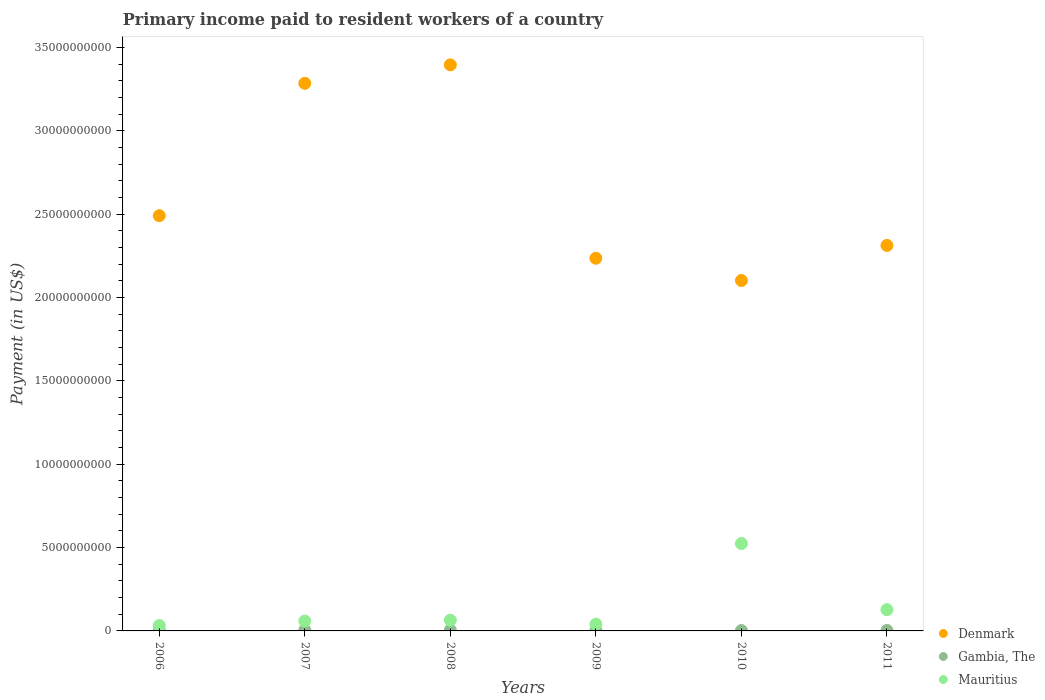How many different coloured dotlines are there?
Provide a short and direct response. 3. What is the amount paid to workers in Mauritius in 2011?
Make the answer very short. 1.28e+09. Across all years, what is the maximum amount paid to workers in Denmark?
Keep it short and to the point. 3.40e+1. Across all years, what is the minimum amount paid to workers in Mauritius?
Your answer should be very brief. 3.24e+08. What is the total amount paid to workers in Denmark in the graph?
Your answer should be very brief. 1.58e+11. What is the difference between the amount paid to workers in Mauritius in 2006 and that in 2008?
Your answer should be very brief. -3.18e+08. What is the difference between the amount paid to workers in Mauritius in 2006 and the amount paid to workers in Gambia, The in 2009?
Ensure brevity in your answer.  3.04e+08. What is the average amount paid to workers in Denmark per year?
Make the answer very short. 2.64e+1. In the year 2006, what is the difference between the amount paid to workers in Mauritius and amount paid to workers in Denmark?
Your answer should be compact. -2.46e+1. In how many years, is the amount paid to workers in Mauritius greater than 16000000000 US$?
Keep it short and to the point. 0. What is the ratio of the amount paid to workers in Denmark in 2010 to that in 2011?
Give a very brief answer. 0.91. Is the amount paid to workers in Mauritius in 2006 less than that in 2011?
Provide a short and direct response. Yes. What is the difference between the highest and the second highest amount paid to workers in Gambia, The?
Make the answer very short. 6.37e+06. What is the difference between the highest and the lowest amount paid to workers in Denmark?
Make the answer very short. 1.29e+1. In how many years, is the amount paid to workers in Denmark greater than the average amount paid to workers in Denmark taken over all years?
Offer a terse response. 2. Is the sum of the amount paid to workers in Gambia, The in 2007 and 2009 greater than the maximum amount paid to workers in Denmark across all years?
Keep it short and to the point. No. Is it the case that in every year, the sum of the amount paid to workers in Gambia, The and amount paid to workers in Mauritius  is greater than the amount paid to workers in Denmark?
Provide a succinct answer. No. Is the amount paid to workers in Gambia, The strictly greater than the amount paid to workers in Mauritius over the years?
Ensure brevity in your answer.  No. Is the amount paid to workers in Denmark strictly less than the amount paid to workers in Mauritius over the years?
Give a very brief answer. No. How many years are there in the graph?
Ensure brevity in your answer.  6. Does the graph contain any zero values?
Keep it short and to the point. No. Does the graph contain grids?
Ensure brevity in your answer.  No. What is the title of the graph?
Your response must be concise. Primary income paid to resident workers of a country. Does "Syrian Arab Republic" appear as one of the legend labels in the graph?
Make the answer very short. No. What is the label or title of the Y-axis?
Provide a succinct answer. Payment (in US$). What is the Payment (in US$) of Denmark in 2006?
Your answer should be very brief. 2.49e+1. What is the Payment (in US$) of Gambia, The in 2006?
Ensure brevity in your answer.  4.24e+07. What is the Payment (in US$) of Mauritius in 2006?
Provide a succinct answer. 3.24e+08. What is the Payment (in US$) in Denmark in 2007?
Provide a short and direct response. 3.29e+1. What is the Payment (in US$) in Gambia, The in 2007?
Make the answer very short. 5.35e+07. What is the Payment (in US$) in Mauritius in 2007?
Your response must be concise. 5.93e+08. What is the Payment (in US$) in Denmark in 2008?
Ensure brevity in your answer.  3.40e+1. What is the Payment (in US$) in Gambia, The in 2008?
Your answer should be very brief. 4.72e+07. What is the Payment (in US$) of Mauritius in 2008?
Provide a succinct answer. 6.42e+08. What is the Payment (in US$) of Denmark in 2009?
Give a very brief answer. 2.24e+1. What is the Payment (in US$) of Gambia, The in 2009?
Ensure brevity in your answer.  1.98e+07. What is the Payment (in US$) of Mauritius in 2009?
Your response must be concise. 4.03e+08. What is the Payment (in US$) in Denmark in 2010?
Provide a succinct answer. 2.10e+1. What is the Payment (in US$) of Gambia, The in 2010?
Ensure brevity in your answer.  2.24e+07. What is the Payment (in US$) of Mauritius in 2010?
Your response must be concise. 5.24e+09. What is the Payment (in US$) in Denmark in 2011?
Your answer should be very brief. 2.31e+1. What is the Payment (in US$) in Gambia, The in 2011?
Make the answer very short. 2.88e+07. What is the Payment (in US$) in Mauritius in 2011?
Give a very brief answer. 1.28e+09. Across all years, what is the maximum Payment (in US$) of Denmark?
Give a very brief answer. 3.40e+1. Across all years, what is the maximum Payment (in US$) in Gambia, The?
Keep it short and to the point. 5.35e+07. Across all years, what is the maximum Payment (in US$) of Mauritius?
Offer a very short reply. 5.24e+09. Across all years, what is the minimum Payment (in US$) in Denmark?
Ensure brevity in your answer.  2.10e+1. Across all years, what is the minimum Payment (in US$) in Gambia, The?
Make the answer very short. 1.98e+07. Across all years, what is the minimum Payment (in US$) in Mauritius?
Your answer should be very brief. 3.24e+08. What is the total Payment (in US$) of Denmark in the graph?
Your answer should be compact. 1.58e+11. What is the total Payment (in US$) of Gambia, The in the graph?
Provide a succinct answer. 2.14e+08. What is the total Payment (in US$) of Mauritius in the graph?
Provide a short and direct response. 8.48e+09. What is the difference between the Payment (in US$) in Denmark in 2006 and that in 2007?
Your answer should be compact. -7.94e+09. What is the difference between the Payment (in US$) in Gambia, The in 2006 and that in 2007?
Offer a terse response. -1.11e+07. What is the difference between the Payment (in US$) of Mauritius in 2006 and that in 2007?
Your answer should be very brief. -2.69e+08. What is the difference between the Payment (in US$) in Denmark in 2006 and that in 2008?
Make the answer very short. -9.05e+09. What is the difference between the Payment (in US$) in Gambia, The in 2006 and that in 2008?
Your answer should be very brief. -4.76e+06. What is the difference between the Payment (in US$) of Mauritius in 2006 and that in 2008?
Give a very brief answer. -3.18e+08. What is the difference between the Payment (in US$) in Denmark in 2006 and that in 2009?
Offer a terse response. 2.55e+09. What is the difference between the Payment (in US$) of Gambia, The in 2006 and that in 2009?
Ensure brevity in your answer.  2.26e+07. What is the difference between the Payment (in US$) of Mauritius in 2006 and that in 2009?
Offer a very short reply. -7.88e+07. What is the difference between the Payment (in US$) of Denmark in 2006 and that in 2010?
Give a very brief answer. 3.89e+09. What is the difference between the Payment (in US$) in Gambia, The in 2006 and that in 2010?
Offer a terse response. 2.00e+07. What is the difference between the Payment (in US$) of Mauritius in 2006 and that in 2010?
Your answer should be very brief. -4.92e+09. What is the difference between the Payment (in US$) of Denmark in 2006 and that in 2011?
Provide a short and direct response. 1.79e+09. What is the difference between the Payment (in US$) of Gambia, The in 2006 and that in 2011?
Your answer should be compact. 1.36e+07. What is the difference between the Payment (in US$) in Mauritius in 2006 and that in 2011?
Provide a short and direct response. -9.52e+08. What is the difference between the Payment (in US$) in Denmark in 2007 and that in 2008?
Offer a terse response. -1.11e+09. What is the difference between the Payment (in US$) of Gambia, The in 2007 and that in 2008?
Offer a very short reply. 6.37e+06. What is the difference between the Payment (in US$) of Mauritius in 2007 and that in 2008?
Give a very brief answer. -4.84e+07. What is the difference between the Payment (in US$) in Denmark in 2007 and that in 2009?
Offer a terse response. 1.05e+1. What is the difference between the Payment (in US$) in Gambia, The in 2007 and that in 2009?
Your answer should be very brief. 3.37e+07. What is the difference between the Payment (in US$) in Mauritius in 2007 and that in 2009?
Provide a succinct answer. 1.91e+08. What is the difference between the Payment (in US$) of Denmark in 2007 and that in 2010?
Provide a succinct answer. 1.18e+1. What is the difference between the Payment (in US$) of Gambia, The in 2007 and that in 2010?
Keep it short and to the point. 3.11e+07. What is the difference between the Payment (in US$) of Mauritius in 2007 and that in 2010?
Give a very brief answer. -4.65e+09. What is the difference between the Payment (in US$) in Denmark in 2007 and that in 2011?
Keep it short and to the point. 9.73e+09. What is the difference between the Payment (in US$) in Gambia, The in 2007 and that in 2011?
Provide a short and direct response. 2.47e+07. What is the difference between the Payment (in US$) in Mauritius in 2007 and that in 2011?
Provide a succinct answer. -6.83e+08. What is the difference between the Payment (in US$) in Denmark in 2008 and that in 2009?
Give a very brief answer. 1.16e+1. What is the difference between the Payment (in US$) in Gambia, The in 2008 and that in 2009?
Make the answer very short. 2.74e+07. What is the difference between the Payment (in US$) in Mauritius in 2008 and that in 2009?
Provide a succinct answer. 2.39e+08. What is the difference between the Payment (in US$) of Denmark in 2008 and that in 2010?
Keep it short and to the point. 1.29e+1. What is the difference between the Payment (in US$) of Gambia, The in 2008 and that in 2010?
Give a very brief answer. 2.48e+07. What is the difference between the Payment (in US$) in Mauritius in 2008 and that in 2010?
Your answer should be very brief. -4.60e+09. What is the difference between the Payment (in US$) in Denmark in 2008 and that in 2011?
Keep it short and to the point. 1.08e+1. What is the difference between the Payment (in US$) in Gambia, The in 2008 and that in 2011?
Give a very brief answer. 1.84e+07. What is the difference between the Payment (in US$) of Mauritius in 2008 and that in 2011?
Provide a succinct answer. -6.34e+08. What is the difference between the Payment (in US$) in Denmark in 2009 and that in 2010?
Ensure brevity in your answer.  1.33e+09. What is the difference between the Payment (in US$) in Gambia, The in 2009 and that in 2010?
Keep it short and to the point. -2.62e+06. What is the difference between the Payment (in US$) in Mauritius in 2009 and that in 2010?
Make the answer very short. -4.84e+09. What is the difference between the Payment (in US$) of Denmark in 2009 and that in 2011?
Your answer should be very brief. -7.68e+08. What is the difference between the Payment (in US$) in Gambia, The in 2009 and that in 2011?
Provide a short and direct response. -9.02e+06. What is the difference between the Payment (in US$) of Mauritius in 2009 and that in 2011?
Offer a terse response. -8.74e+08. What is the difference between the Payment (in US$) in Denmark in 2010 and that in 2011?
Make the answer very short. -2.10e+09. What is the difference between the Payment (in US$) of Gambia, The in 2010 and that in 2011?
Your answer should be very brief. -6.40e+06. What is the difference between the Payment (in US$) in Mauritius in 2010 and that in 2011?
Provide a succinct answer. 3.97e+09. What is the difference between the Payment (in US$) in Denmark in 2006 and the Payment (in US$) in Gambia, The in 2007?
Provide a short and direct response. 2.49e+1. What is the difference between the Payment (in US$) of Denmark in 2006 and the Payment (in US$) of Mauritius in 2007?
Your answer should be compact. 2.43e+1. What is the difference between the Payment (in US$) in Gambia, The in 2006 and the Payment (in US$) in Mauritius in 2007?
Make the answer very short. -5.51e+08. What is the difference between the Payment (in US$) of Denmark in 2006 and the Payment (in US$) of Gambia, The in 2008?
Offer a very short reply. 2.49e+1. What is the difference between the Payment (in US$) of Denmark in 2006 and the Payment (in US$) of Mauritius in 2008?
Make the answer very short. 2.43e+1. What is the difference between the Payment (in US$) in Gambia, The in 2006 and the Payment (in US$) in Mauritius in 2008?
Provide a succinct answer. -5.99e+08. What is the difference between the Payment (in US$) in Denmark in 2006 and the Payment (in US$) in Gambia, The in 2009?
Provide a short and direct response. 2.49e+1. What is the difference between the Payment (in US$) in Denmark in 2006 and the Payment (in US$) in Mauritius in 2009?
Provide a short and direct response. 2.45e+1. What is the difference between the Payment (in US$) of Gambia, The in 2006 and the Payment (in US$) of Mauritius in 2009?
Ensure brevity in your answer.  -3.60e+08. What is the difference between the Payment (in US$) of Denmark in 2006 and the Payment (in US$) of Gambia, The in 2010?
Offer a terse response. 2.49e+1. What is the difference between the Payment (in US$) of Denmark in 2006 and the Payment (in US$) of Mauritius in 2010?
Your response must be concise. 1.97e+1. What is the difference between the Payment (in US$) of Gambia, The in 2006 and the Payment (in US$) of Mauritius in 2010?
Your answer should be very brief. -5.20e+09. What is the difference between the Payment (in US$) in Denmark in 2006 and the Payment (in US$) in Gambia, The in 2011?
Offer a terse response. 2.49e+1. What is the difference between the Payment (in US$) in Denmark in 2006 and the Payment (in US$) in Mauritius in 2011?
Your answer should be compact. 2.36e+1. What is the difference between the Payment (in US$) in Gambia, The in 2006 and the Payment (in US$) in Mauritius in 2011?
Make the answer very short. -1.23e+09. What is the difference between the Payment (in US$) of Denmark in 2007 and the Payment (in US$) of Gambia, The in 2008?
Your answer should be very brief. 3.28e+1. What is the difference between the Payment (in US$) of Denmark in 2007 and the Payment (in US$) of Mauritius in 2008?
Your response must be concise. 3.22e+1. What is the difference between the Payment (in US$) in Gambia, The in 2007 and the Payment (in US$) in Mauritius in 2008?
Keep it short and to the point. -5.88e+08. What is the difference between the Payment (in US$) in Denmark in 2007 and the Payment (in US$) in Gambia, The in 2009?
Your answer should be very brief. 3.28e+1. What is the difference between the Payment (in US$) of Denmark in 2007 and the Payment (in US$) of Mauritius in 2009?
Make the answer very short. 3.24e+1. What is the difference between the Payment (in US$) in Gambia, The in 2007 and the Payment (in US$) in Mauritius in 2009?
Ensure brevity in your answer.  -3.49e+08. What is the difference between the Payment (in US$) of Denmark in 2007 and the Payment (in US$) of Gambia, The in 2010?
Your response must be concise. 3.28e+1. What is the difference between the Payment (in US$) in Denmark in 2007 and the Payment (in US$) in Mauritius in 2010?
Your response must be concise. 2.76e+1. What is the difference between the Payment (in US$) in Gambia, The in 2007 and the Payment (in US$) in Mauritius in 2010?
Offer a very short reply. -5.19e+09. What is the difference between the Payment (in US$) in Denmark in 2007 and the Payment (in US$) in Gambia, The in 2011?
Offer a very short reply. 3.28e+1. What is the difference between the Payment (in US$) of Denmark in 2007 and the Payment (in US$) of Mauritius in 2011?
Ensure brevity in your answer.  3.16e+1. What is the difference between the Payment (in US$) in Gambia, The in 2007 and the Payment (in US$) in Mauritius in 2011?
Keep it short and to the point. -1.22e+09. What is the difference between the Payment (in US$) of Denmark in 2008 and the Payment (in US$) of Gambia, The in 2009?
Offer a very short reply. 3.39e+1. What is the difference between the Payment (in US$) of Denmark in 2008 and the Payment (in US$) of Mauritius in 2009?
Your answer should be compact. 3.36e+1. What is the difference between the Payment (in US$) in Gambia, The in 2008 and the Payment (in US$) in Mauritius in 2009?
Provide a short and direct response. -3.55e+08. What is the difference between the Payment (in US$) of Denmark in 2008 and the Payment (in US$) of Gambia, The in 2010?
Make the answer very short. 3.39e+1. What is the difference between the Payment (in US$) of Denmark in 2008 and the Payment (in US$) of Mauritius in 2010?
Provide a short and direct response. 2.87e+1. What is the difference between the Payment (in US$) in Gambia, The in 2008 and the Payment (in US$) in Mauritius in 2010?
Offer a terse response. -5.19e+09. What is the difference between the Payment (in US$) in Denmark in 2008 and the Payment (in US$) in Gambia, The in 2011?
Provide a succinct answer. 3.39e+1. What is the difference between the Payment (in US$) in Denmark in 2008 and the Payment (in US$) in Mauritius in 2011?
Make the answer very short. 3.27e+1. What is the difference between the Payment (in US$) of Gambia, The in 2008 and the Payment (in US$) of Mauritius in 2011?
Your answer should be very brief. -1.23e+09. What is the difference between the Payment (in US$) of Denmark in 2009 and the Payment (in US$) of Gambia, The in 2010?
Make the answer very short. 2.23e+1. What is the difference between the Payment (in US$) in Denmark in 2009 and the Payment (in US$) in Mauritius in 2010?
Ensure brevity in your answer.  1.71e+1. What is the difference between the Payment (in US$) of Gambia, The in 2009 and the Payment (in US$) of Mauritius in 2010?
Ensure brevity in your answer.  -5.22e+09. What is the difference between the Payment (in US$) of Denmark in 2009 and the Payment (in US$) of Gambia, The in 2011?
Ensure brevity in your answer.  2.23e+1. What is the difference between the Payment (in US$) in Denmark in 2009 and the Payment (in US$) in Mauritius in 2011?
Offer a terse response. 2.11e+1. What is the difference between the Payment (in US$) in Gambia, The in 2009 and the Payment (in US$) in Mauritius in 2011?
Your answer should be very brief. -1.26e+09. What is the difference between the Payment (in US$) in Denmark in 2010 and the Payment (in US$) in Gambia, The in 2011?
Give a very brief answer. 2.10e+1. What is the difference between the Payment (in US$) in Denmark in 2010 and the Payment (in US$) in Mauritius in 2011?
Offer a very short reply. 1.97e+1. What is the difference between the Payment (in US$) of Gambia, The in 2010 and the Payment (in US$) of Mauritius in 2011?
Give a very brief answer. -1.25e+09. What is the average Payment (in US$) of Denmark per year?
Give a very brief answer. 2.64e+1. What is the average Payment (in US$) of Gambia, The per year?
Your answer should be compact. 3.57e+07. What is the average Payment (in US$) in Mauritius per year?
Provide a short and direct response. 1.41e+09. In the year 2006, what is the difference between the Payment (in US$) of Denmark and Payment (in US$) of Gambia, The?
Your response must be concise. 2.49e+1. In the year 2006, what is the difference between the Payment (in US$) of Denmark and Payment (in US$) of Mauritius?
Offer a very short reply. 2.46e+1. In the year 2006, what is the difference between the Payment (in US$) of Gambia, The and Payment (in US$) of Mauritius?
Provide a short and direct response. -2.81e+08. In the year 2007, what is the difference between the Payment (in US$) in Denmark and Payment (in US$) in Gambia, The?
Offer a very short reply. 3.28e+1. In the year 2007, what is the difference between the Payment (in US$) in Denmark and Payment (in US$) in Mauritius?
Offer a very short reply. 3.23e+1. In the year 2007, what is the difference between the Payment (in US$) in Gambia, The and Payment (in US$) in Mauritius?
Provide a succinct answer. -5.40e+08. In the year 2008, what is the difference between the Payment (in US$) of Denmark and Payment (in US$) of Gambia, The?
Keep it short and to the point. 3.39e+1. In the year 2008, what is the difference between the Payment (in US$) of Denmark and Payment (in US$) of Mauritius?
Your answer should be very brief. 3.33e+1. In the year 2008, what is the difference between the Payment (in US$) in Gambia, The and Payment (in US$) in Mauritius?
Your response must be concise. -5.95e+08. In the year 2009, what is the difference between the Payment (in US$) in Denmark and Payment (in US$) in Gambia, The?
Give a very brief answer. 2.23e+1. In the year 2009, what is the difference between the Payment (in US$) of Denmark and Payment (in US$) of Mauritius?
Your answer should be very brief. 2.20e+1. In the year 2009, what is the difference between the Payment (in US$) of Gambia, The and Payment (in US$) of Mauritius?
Make the answer very short. -3.83e+08. In the year 2010, what is the difference between the Payment (in US$) in Denmark and Payment (in US$) in Gambia, The?
Your response must be concise. 2.10e+1. In the year 2010, what is the difference between the Payment (in US$) in Denmark and Payment (in US$) in Mauritius?
Keep it short and to the point. 1.58e+1. In the year 2010, what is the difference between the Payment (in US$) of Gambia, The and Payment (in US$) of Mauritius?
Provide a succinct answer. -5.22e+09. In the year 2011, what is the difference between the Payment (in US$) in Denmark and Payment (in US$) in Gambia, The?
Offer a very short reply. 2.31e+1. In the year 2011, what is the difference between the Payment (in US$) of Denmark and Payment (in US$) of Mauritius?
Provide a succinct answer. 2.18e+1. In the year 2011, what is the difference between the Payment (in US$) of Gambia, The and Payment (in US$) of Mauritius?
Offer a very short reply. -1.25e+09. What is the ratio of the Payment (in US$) of Denmark in 2006 to that in 2007?
Provide a succinct answer. 0.76. What is the ratio of the Payment (in US$) in Gambia, The in 2006 to that in 2007?
Give a very brief answer. 0.79. What is the ratio of the Payment (in US$) in Mauritius in 2006 to that in 2007?
Provide a succinct answer. 0.55. What is the ratio of the Payment (in US$) in Denmark in 2006 to that in 2008?
Your answer should be compact. 0.73. What is the ratio of the Payment (in US$) in Gambia, The in 2006 to that in 2008?
Your answer should be compact. 0.9. What is the ratio of the Payment (in US$) of Mauritius in 2006 to that in 2008?
Your answer should be compact. 0.5. What is the ratio of the Payment (in US$) in Denmark in 2006 to that in 2009?
Offer a terse response. 1.11. What is the ratio of the Payment (in US$) of Gambia, The in 2006 to that in 2009?
Make the answer very short. 2.14. What is the ratio of the Payment (in US$) of Mauritius in 2006 to that in 2009?
Provide a short and direct response. 0.8. What is the ratio of the Payment (in US$) in Denmark in 2006 to that in 2010?
Offer a terse response. 1.19. What is the ratio of the Payment (in US$) of Gambia, The in 2006 to that in 2010?
Your answer should be very brief. 1.89. What is the ratio of the Payment (in US$) in Mauritius in 2006 to that in 2010?
Your answer should be very brief. 0.06. What is the ratio of the Payment (in US$) in Denmark in 2006 to that in 2011?
Make the answer very short. 1.08. What is the ratio of the Payment (in US$) of Gambia, The in 2006 to that in 2011?
Ensure brevity in your answer.  1.47. What is the ratio of the Payment (in US$) of Mauritius in 2006 to that in 2011?
Keep it short and to the point. 0.25. What is the ratio of the Payment (in US$) in Denmark in 2007 to that in 2008?
Ensure brevity in your answer.  0.97. What is the ratio of the Payment (in US$) in Gambia, The in 2007 to that in 2008?
Your answer should be compact. 1.14. What is the ratio of the Payment (in US$) in Mauritius in 2007 to that in 2008?
Keep it short and to the point. 0.92. What is the ratio of the Payment (in US$) in Denmark in 2007 to that in 2009?
Your answer should be compact. 1.47. What is the ratio of the Payment (in US$) of Gambia, The in 2007 to that in 2009?
Provide a short and direct response. 2.71. What is the ratio of the Payment (in US$) of Mauritius in 2007 to that in 2009?
Your response must be concise. 1.47. What is the ratio of the Payment (in US$) in Denmark in 2007 to that in 2010?
Your answer should be compact. 1.56. What is the ratio of the Payment (in US$) of Gambia, The in 2007 to that in 2010?
Ensure brevity in your answer.  2.39. What is the ratio of the Payment (in US$) of Mauritius in 2007 to that in 2010?
Provide a succinct answer. 0.11. What is the ratio of the Payment (in US$) of Denmark in 2007 to that in 2011?
Ensure brevity in your answer.  1.42. What is the ratio of the Payment (in US$) of Gambia, The in 2007 to that in 2011?
Make the answer very short. 1.86. What is the ratio of the Payment (in US$) in Mauritius in 2007 to that in 2011?
Your answer should be compact. 0.46. What is the ratio of the Payment (in US$) of Denmark in 2008 to that in 2009?
Offer a very short reply. 1.52. What is the ratio of the Payment (in US$) in Gambia, The in 2008 to that in 2009?
Offer a terse response. 2.38. What is the ratio of the Payment (in US$) of Mauritius in 2008 to that in 2009?
Provide a short and direct response. 1.59. What is the ratio of the Payment (in US$) in Denmark in 2008 to that in 2010?
Your answer should be very brief. 1.62. What is the ratio of the Payment (in US$) in Gambia, The in 2008 to that in 2010?
Give a very brief answer. 2.11. What is the ratio of the Payment (in US$) in Mauritius in 2008 to that in 2010?
Your response must be concise. 0.12. What is the ratio of the Payment (in US$) of Denmark in 2008 to that in 2011?
Give a very brief answer. 1.47. What is the ratio of the Payment (in US$) of Gambia, The in 2008 to that in 2011?
Provide a succinct answer. 1.64. What is the ratio of the Payment (in US$) in Mauritius in 2008 to that in 2011?
Make the answer very short. 0.5. What is the ratio of the Payment (in US$) of Denmark in 2009 to that in 2010?
Offer a very short reply. 1.06. What is the ratio of the Payment (in US$) in Gambia, The in 2009 to that in 2010?
Keep it short and to the point. 0.88. What is the ratio of the Payment (in US$) in Mauritius in 2009 to that in 2010?
Give a very brief answer. 0.08. What is the ratio of the Payment (in US$) of Denmark in 2009 to that in 2011?
Offer a terse response. 0.97. What is the ratio of the Payment (in US$) in Gambia, The in 2009 to that in 2011?
Your answer should be compact. 0.69. What is the ratio of the Payment (in US$) in Mauritius in 2009 to that in 2011?
Offer a very short reply. 0.32. What is the ratio of the Payment (in US$) in Denmark in 2010 to that in 2011?
Your answer should be compact. 0.91. What is the ratio of the Payment (in US$) in Gambia, The in 2010 to that in 2011?
Offer a terse response. 0.78. What is the ratio of the Payment (in US$) of Mauritius in 2010 to that in 2011?
Your response must be concise. 4.11. What is the difference between the highest and the second highest Payment (in US$) of Denmark?
Your answer should be very brief. 1.11e+09. What is the difference between the highest and the second highest Payment (in US$) in Gambia, The?
Your answer should be very brief. 6.37e+06. What is the difference between the highest and the second highest Payment (in US$) in Mauritius?
Keep it short and to the point. 3.97e+09. What is the difference between the highest and the lowest Payment (in US$) of Denmark?
Give a very brief answer. 1.29e+1. What is the difference between the highest and the lowest Payment (in US$) of Gambia, The?
Provide a succinct answer. 3.37e+07. What is the difference between the highest and the lowest Payment (in US$) in Mauritius?
Give a very brief answer. 4.92e+09. 